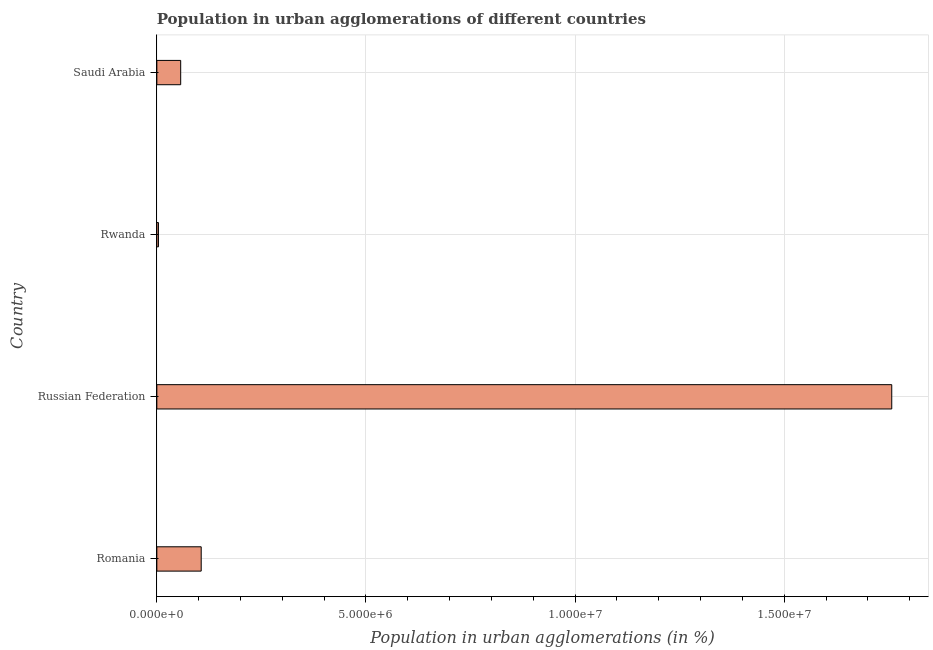Does the graph contain grids?
Offer a terse response. Yes. What is the title of the graph?
Your answer should be compact. Population in urban agglomerations of different countries. What is the label or title of the X-axis?
Ensure brevity in your answer.  Population in urban agglomerations (in %). What is the label or title of the Y-axis?
Offer a terse response. Country. What is the population in urban agglomerations in Saudi Arabia?
Make the answer very short. 5.70e+05. Across all countries, what is the maximum population in urban agglomerations?
Offer a very short reply. 1.76e+07. Across all countries, what is the minimum population in urban agglomerations?
Your answer should be very brief. 3.83e+04. In which country was the population in urban agglomerations maximum?
Ensure brevity in your answer.  Russian Federation. In which country was the population in urban agglomerations minimum?
Your response must be concise. Rwanda. What is the sum of the population in urban agglomerations?
Provide a short and direct response. 1.92e+07. What is the difference between the population in urban agglomerations in Rwanda and Saudi Arabia?
Your answer should be compact. -5.32e+05. What is the average population in urban agglomerations per country?
Give a very brief answer. 4.81e+06. What is the median population in urban agglomerations?
Provide a short and direct response. 8.15e+05. In how many countries, is the population in urban agglomerations greater than 14000000 %?
Your response must be concise. 1. What is the ratio of the population in urban agglomerations in Romania to that in Russian Federation?
Keep it short and to the point. 0.06. Is the population in urban agglomerations in Romania less than that in Saudi Arabia?
Your response must be concise. No. What is the difference between the highest and the second highest population in urban agglomerations?
Give a very brief answer. 1.65e+07. Is the sum of the population in urban agglomerations in Romania and Rwanda greater than the maximum population in urban agglomerations across all countries?
Offer a very short reply. No. What is the difference between the highest and the lowest population in urban agglomerations?
Provide a short and direct response. 1.75e+07. How many bars are there?
Your answer should be very brief. 4. How many countries are there in the graph?
Your response must be concise. 4. What is the Population in urban agglomerations (in %) of Romania?
Make the answer very short. 1.06e+06. What is the Population in urban agglomerations (in %) of Russian Federation?
Offer a terse response. 1.76e+07. What is the Population in urban agglomerations (in %) in Rwanda?
Your response must be concise. 3.83e+04. What is the Population in urban agglomerations (in %) in Saudi Arabia?
Keep it short and to the point. 5.70e+05. What is the difference between the Population in urban agglomerations (in %) in Romania and Russian Federation?
Offer a very short reply. -1.65e+07. What is the difference between the Population in urban agglomerations (in %) in Romania and Rwanda?
Provide a succinct answer. 1.02e+06. What is the difference between the Population in urban agglomerations (in %) in Romania and Saudi Arabia?
Your response must be concise. 4.91e+05. What is the difference between the Population in urban agglomerations (in %) in Russian Federation and Rwanda?
Offer a terse response. 1.75e+07. What is the difference between the Population in urban agglomerations (in %) in Russian Federation and Saudi Arabia?
Offer a terse response. 1.70e+07. What is the difference between the Population in urban agglomerations (in %) in Rwanda and Saudi Arabia?
Ensure brevity in your answer.  -5.32e+05. What is the ratio of the Population in urban agglomerations (in %) in Romania to that in Rwanda?
Offer a very short reply. 27.7. What is the ratio of the Population in urban agglomerations (in %) in Romania to that in Saudi Arabia?
Make the answer very short. 1.86. What is the ratio of the Population in urban agglomerations (in %) in Russian Federation to that in Rwanda?
Make the answer very short. 458.83. What is the ratio of the Population in urban agglomerations (in %) in Russian Federation to that in Saudi Arabia?
Make the answer very short. 30.83. What is the ratio of the Population in urban agglomerations (in %) in Rwanda to that in Saudi Arabia?
Your answer should be very brief. 0.07. 